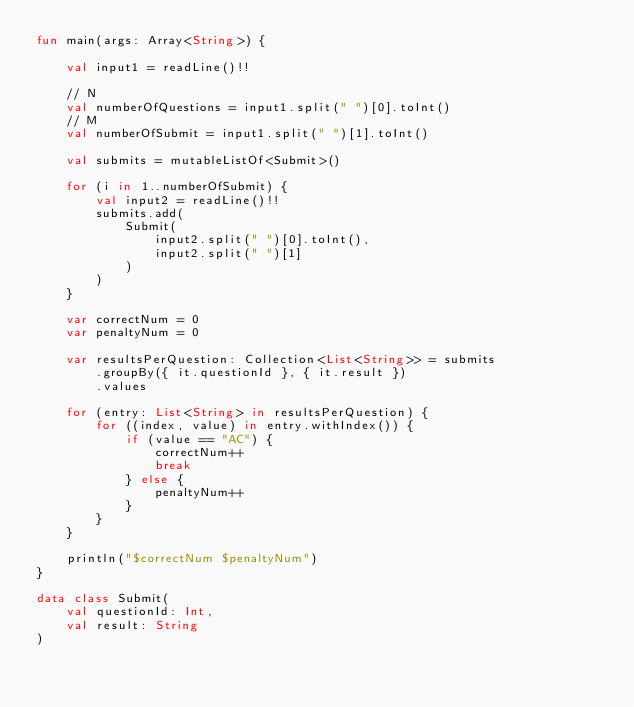<code> <loc_0><loc_0><loc_500><loc_500><_Kotlin_>fun main(args: Array<String>) {

    val input1 = readLine()!!

    // N
    val numberOfQuestions = input1.split(" ")[0].toInt()
    // M
    val numberOfSubmit = input1.split(" ")[1].toInt()

    val submits = mutableListOf<Submit>()

    for (i in 1..numberOfSubmit) {
        val input2 = readLine()!!
        submits.add(
            Submit(
                input2.split(" ")[0].toInt(),
                input2.split(" ")[1]
            )
        )
    }

    var correctNum = 0
    var penaltyNum = 0

    var resultsPerQuestion: Collection<List<String>> = submits
        .groupBy({ it.questionId }, { it.result })
        .values

    for (entry: List<String> in resultsPerQuestion) {
        for ((index, value) in entry.withIndex()) {
            if (value == "AC") {
                correctNum++
                break
            } else {
                penaltyNum++
            }
        }
    }

    println("$correctNum $penaltyNum")
}

data class Submit(
    val questionId: Int,
    val result: String
)</code> 